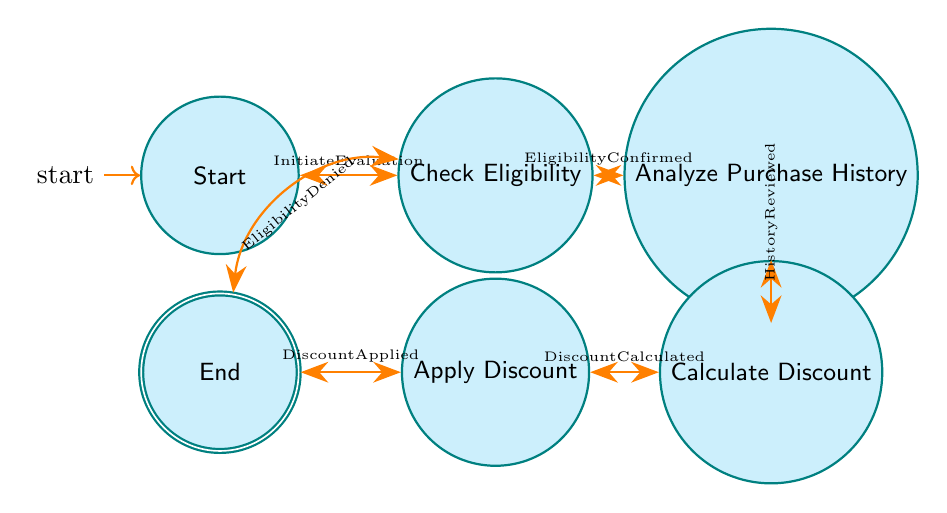What is the initial state of the evaluation process? The initial state is labeled as "Start", indicating where the evaluation begins.
Answer: Start How many nodes are present in the diagram? The diagram contains a total of six states (nodes): Start, Check Eligibility, Analyze Purchase History, Calculate Discount, Apply Discount, and End.
Answer: Six Which state follows "Check Eligibility" if eligibility is confirmed? If eligibility is confirmed, the process transitions from "Check Eligibility" to "Analyze Purchase History".
Answer: Analyze Purchase History What happens if a customer does not meet the eligibility criteria? If the customer does not meet the eligibility criteria, the process will transition from "Check Eligibility" directly to "End".
Answer: End What is the last state in the evaluation process? The last state, where the evaluation process concludes, is labeled as "End".
Answer: End What triggers the transition from "Analyze Purchase History" to "Calculate Discount"? The transition from "Analyze Purchase History" to "Calculate Discount" is triggered by the condition that the purchase history has been reviewed.
Answer: History Reviewed Which edge connects "Apply Discount" to "End"? The edge connecting "Apply Discount" to "End" indicates that the discount has been successfully applied, leading to the conclusion of the process.
Answer: Discount Applied Which state does the process return to after confirming eligibility? Upon confirming eligibility, the process transitions to the state "Analyze Purchase History".
Answer: Analyze Purchase History If the discount has been calculated successfully, what is the next state? If the discount has been calculated successfully, the next state will be "Apply Discount".
Answer: Apply Discount 